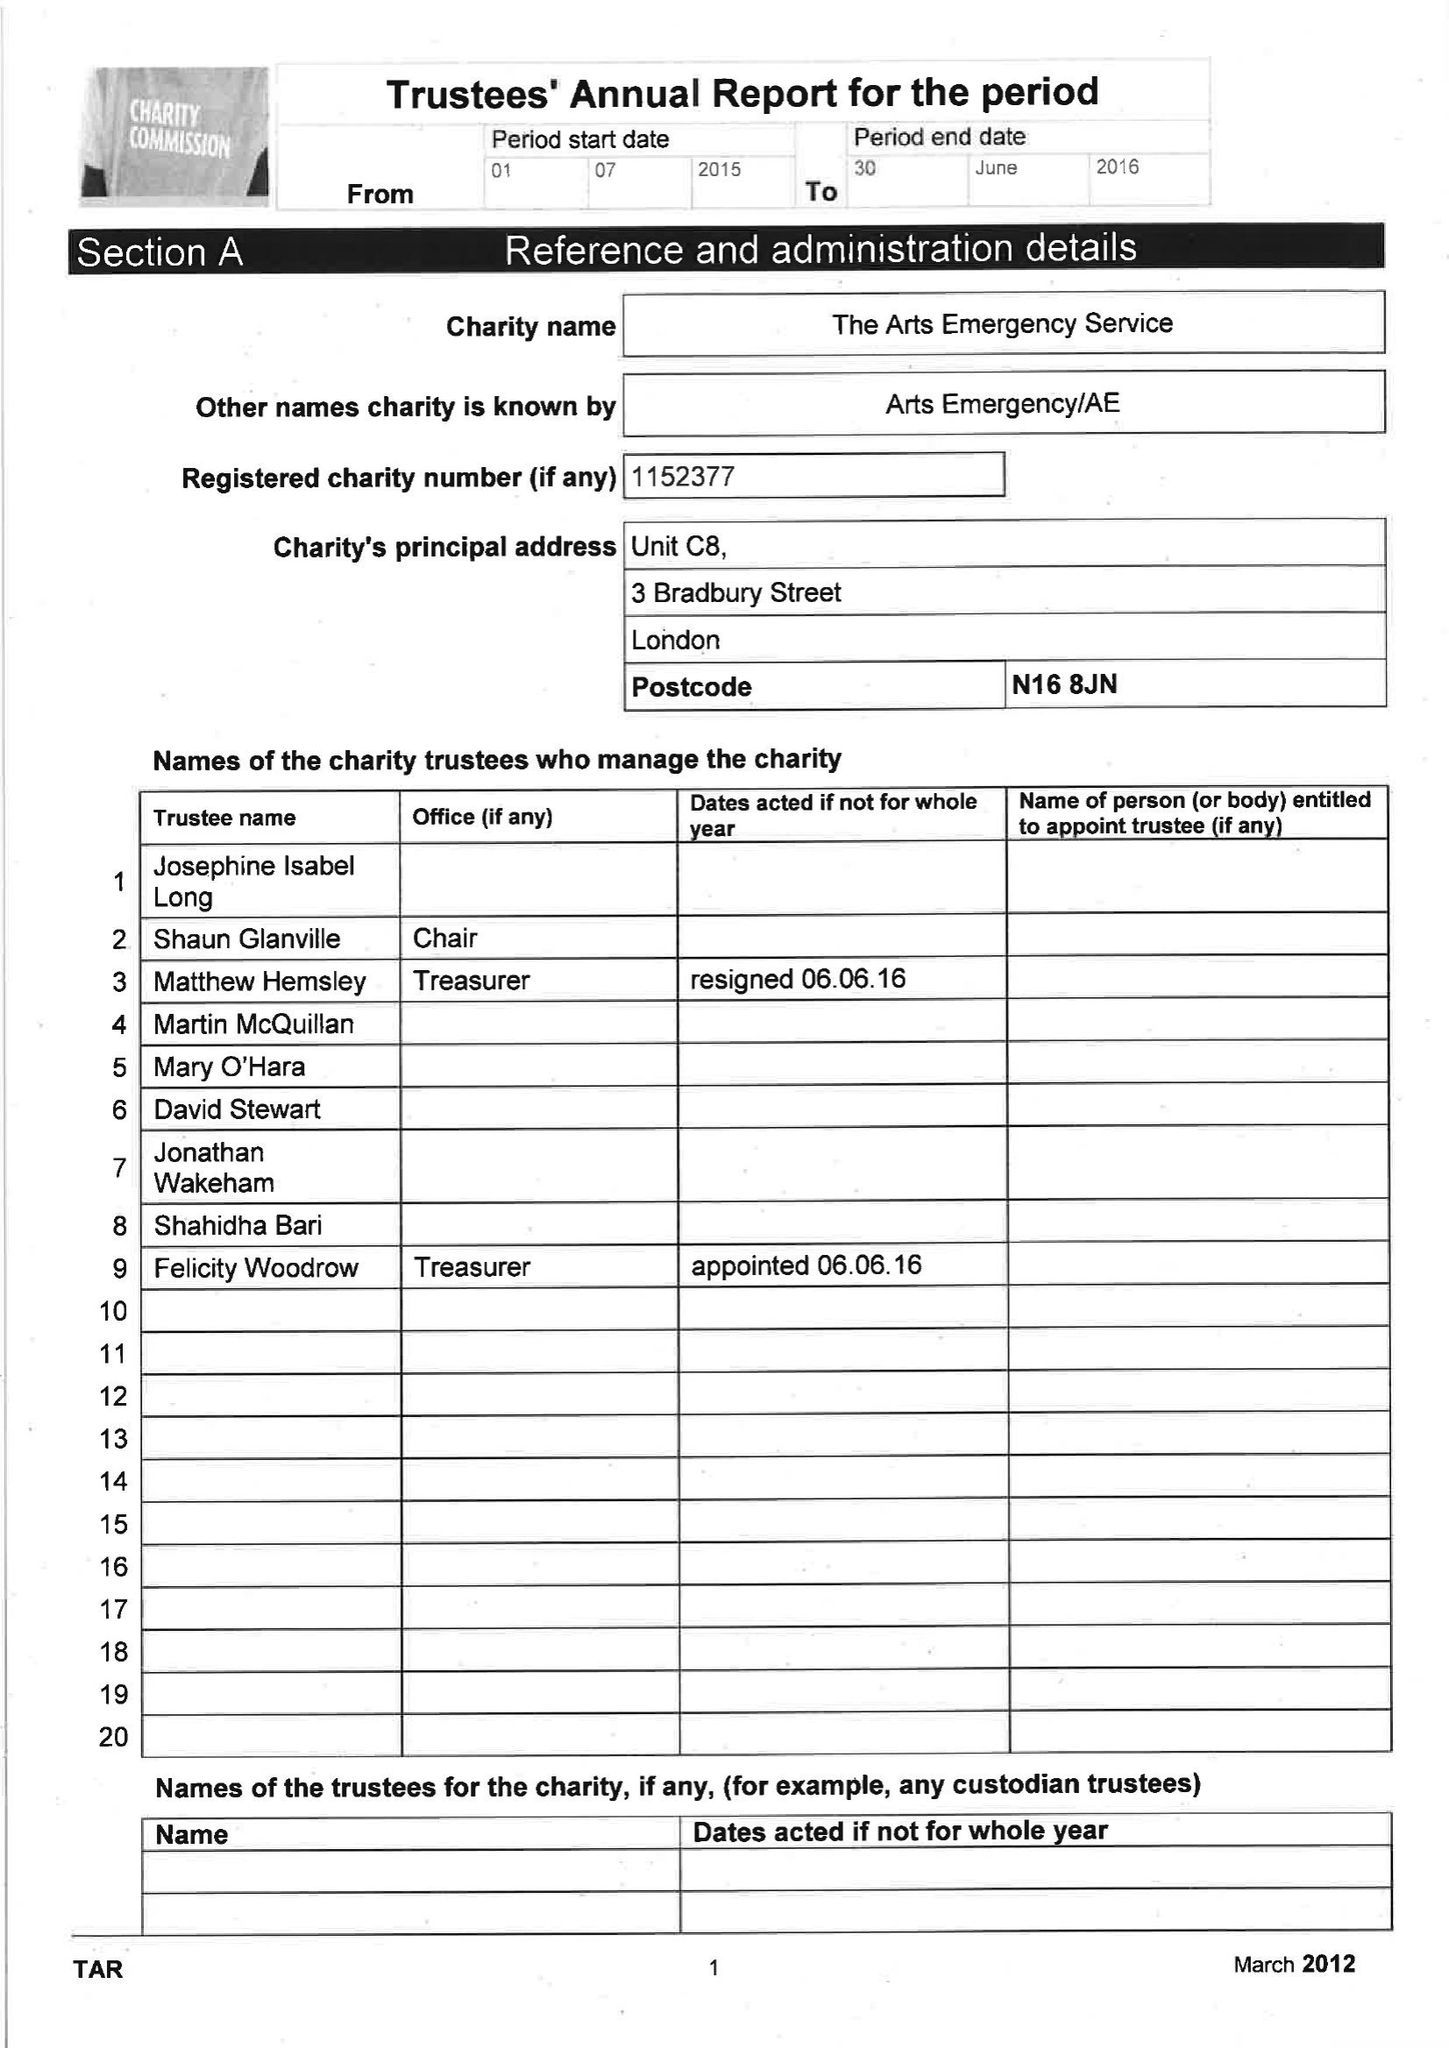What is the value for the address__postcode?
Answer the question using a single word or phrase. N4 2TG 